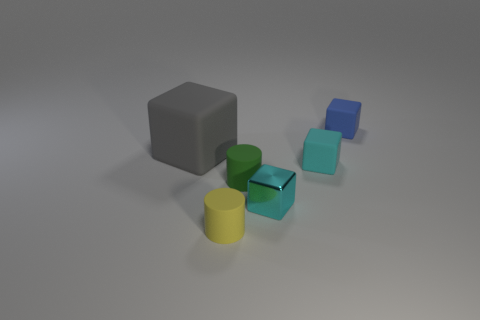Add 2 cyan shiny blocks. How many objects exist? 8 Subtract all cylinders. How many objects are left? 4 Subtract 0 yellow cubes. How many objects are left? 6 Subtract all small cylinders. Subtract all small red cubes. How many objects are left? 4 Add 3 small blue rubber blocks. How many small blue rubber blocks are left? 4 Add 3 green rubber cylinders. How many green rubber cylinders exist? 4 